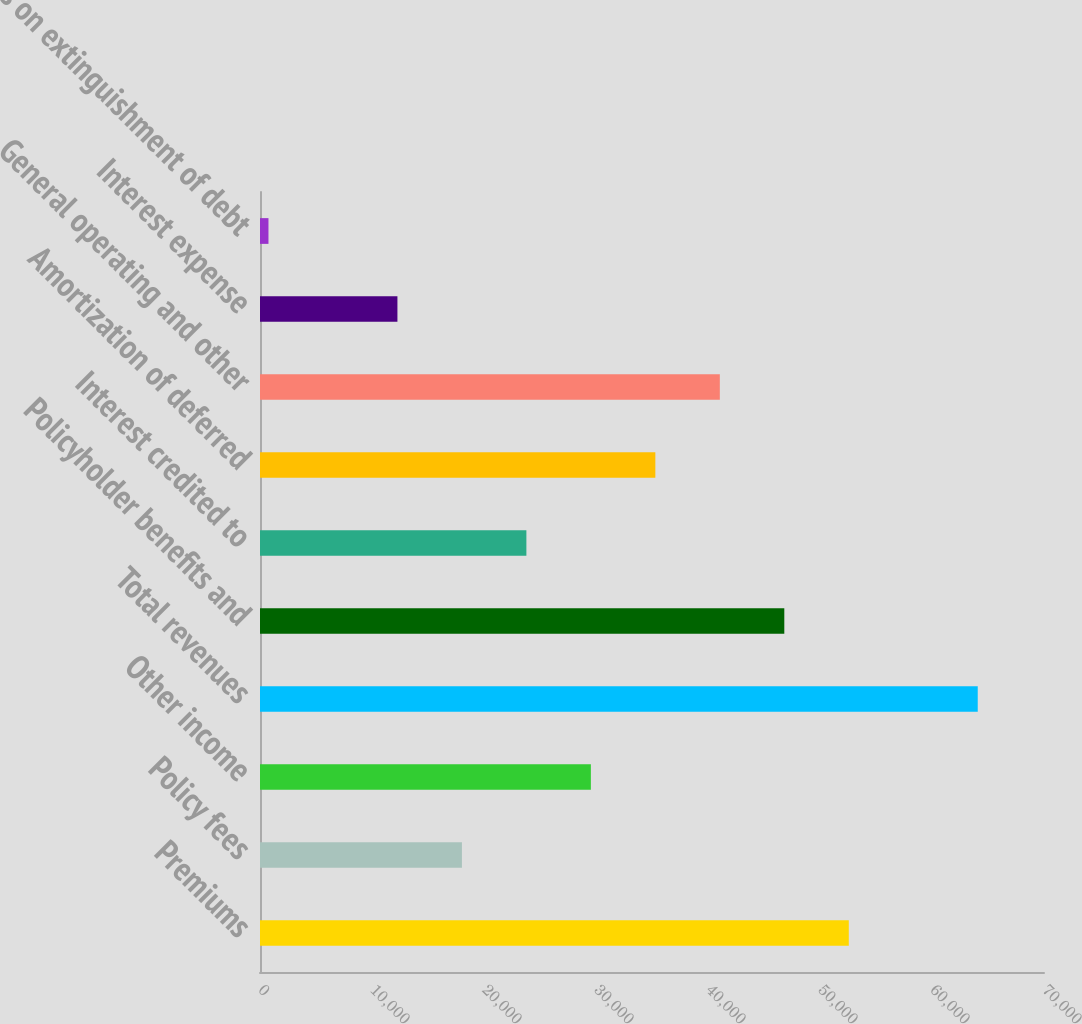<chart> <loc_0><loc_0><loc_500><loc_500><bar_chart><fcel>Premiums<fcel>Policy fees<fcel>Other income<fcel>Total revenues<fcel>Policyholder benefits and<fcel>Interest credited to<fcel>Amortization of deferred<fcel>General operating and other<fcel>Interest expense<fcel>Loss on extinguishment of debt<nl><fcel>52569.9<fcel>18027.3<fcel>29541.5<fcel>64084.1<fcel>46812.8<fcel>23784.4<fcel>35298.6<fcel>41055.7<fcel>12270.2<fcel>756<nl></chart> 